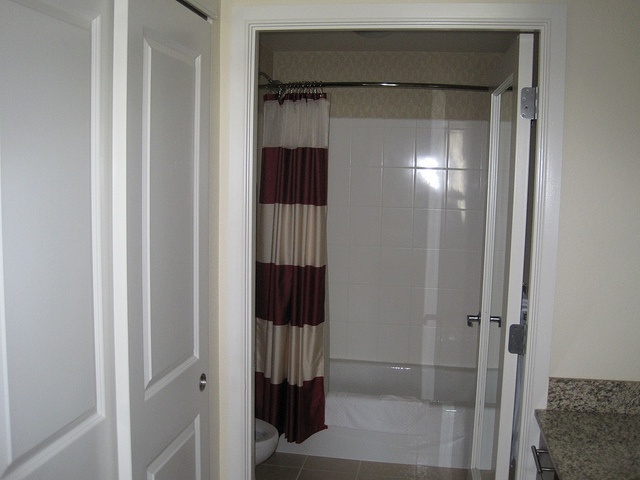Describe the objects in this image and their specific colors. I can see a toilet in gray and black tones in this image. 